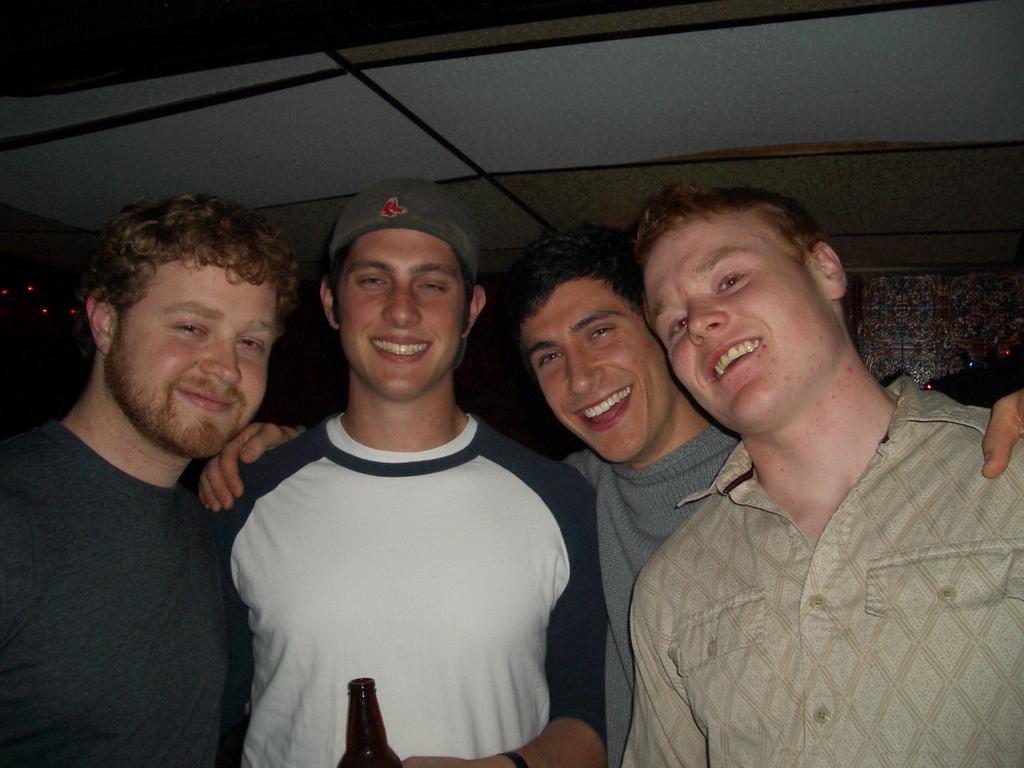How would you summarize this image in a sentence or two? In the center of the image there are people. In the background of the image there is wall. At the top of the image there is ceiling. 